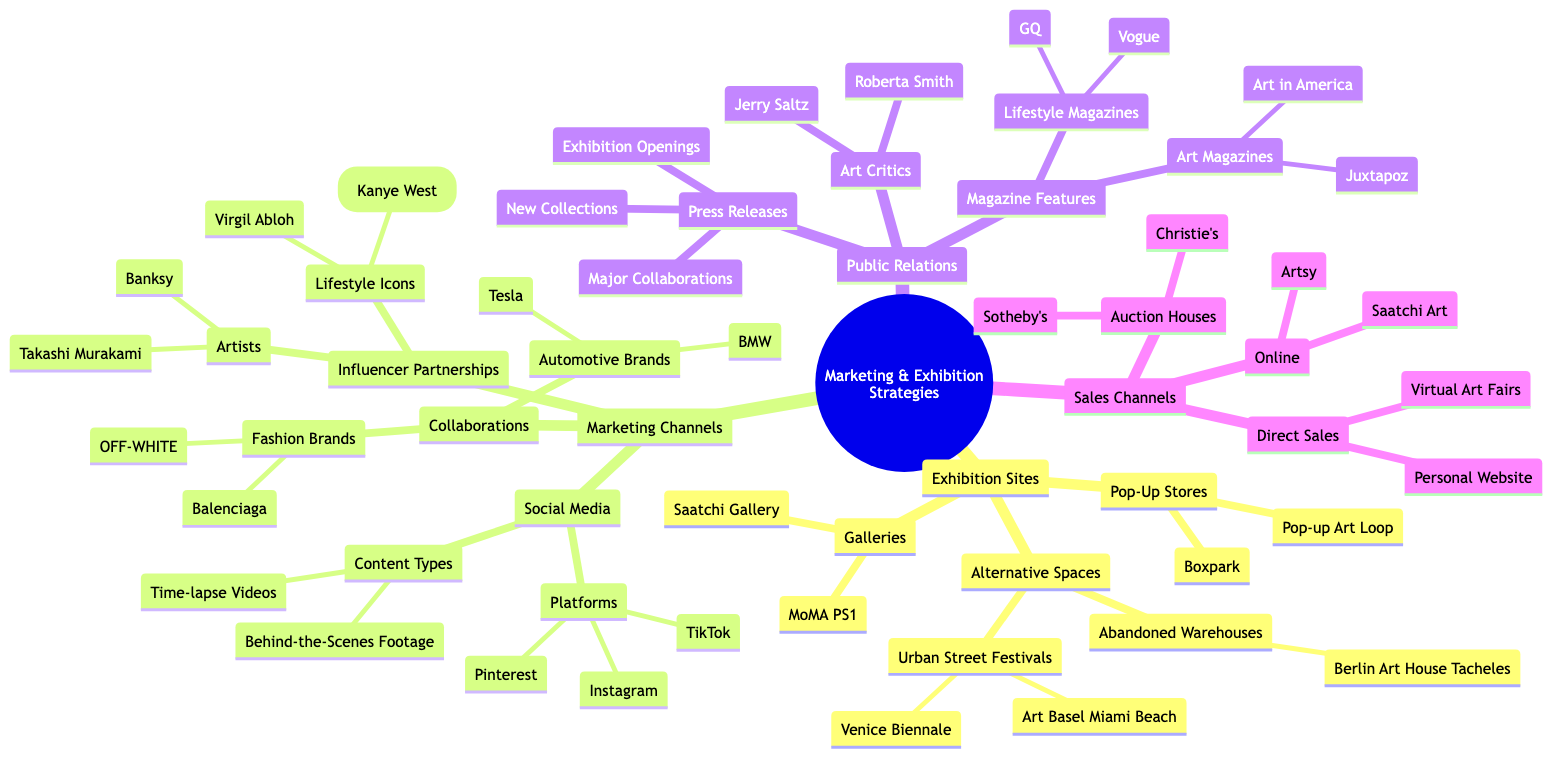What are two exhibition sites listed? The diagram indicates three categories under "Exhibition Sites": Galleries, Alternative Spaces, and Pop-Up Stores. In the Galleries category, two specific names are provided, which are MoMA PS1 and Saatchi Gallery.
Answer: MoMA PS1, Saatchi Gallery How many social media platforms are listed? Under the "Marketing Channels" section, specifically within "Social Media," there is a subcategory called "Platforms" that contains three entries: Instagram, TikTok, and Pinterest. Thus, the total count is three.
Answer: 3 Which automotive brand is associated with the "Art Car Series"? Within the "Collaborations" subcategory under "Marketing Channels," we find the "Automotive Brands" list. Tesla is mentioned alongside its collaboration type, which is the "Art Car Series."
Answer: Tesla Name one lifestyle icon mentioned under influencer partnerships. The "Influencer Partnerships" section consists of two categories: Artists and Lifestyle Icons. Under the latter, Virgil Abloh is listed as an example, making him one potential answer.
Answer: Virgil Abloh What topics are covered in the press releases? In the "Public Relations" category, the subcategory "Press Releases" lists three specific topics: New Collections, Major Collaborations, and Exhibition Openings. Therefore, one of those topics is a valid answer.
Answer: New Collections How many auction houses are mentioned in sales channels? The "Sales Channels" section includes a category for "Auction Houses," where two names are specifically listed: Christie's and Sotheby's. Thus, the total number of auction houses mentioned is two.
Answer: 2 Which magazine features are listed under lifestyle magazines? In the "Public Relations" category, there is a subcategory for "Magazine Features," which has a section for "Lifestyle Magazines" that names two specific magazines: Vogue and GQ. These magazines represent the features being referred to in the question.
Answer: Vogue, GQ What is one example of an alternative space for exhibitions? Within the "Alternative Spaces" category under "Exhibition Sites," there are two examples listed: Urban Street Festivals and Abandoned Warehouses. Urban Street Festivals is one of the valid responses.
Answer: Urban Street Festivals 